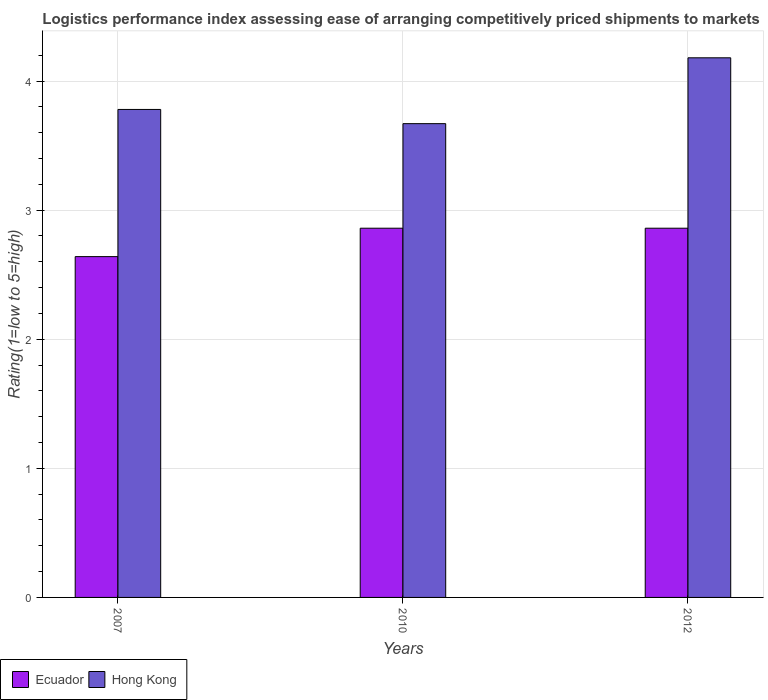Are the number of bars per tick equal to the number of legend labels?
Offer a very short reply. Yes. Are the number of bars on each tick of the X-axis equal?
Provide a short and direct response. Yes. What is the label of the 3rd group of bars from the left?
Your answer should be compact. 2012. In how many cases, is the number of bars for a given year not equal to the number of legend labels?
Ensure brevity in your answer.  0. What is the Logistic performance index in Hong Kong in 2012?
Offer a very short reply. 4.18. Across all years, what is the maximum Logistic performance index in Ecuador?
Offer a very short reply. 2.86. Across all years, what is the minimum Logistic performance index in Ecuador?
Provide a short and direct response. 2.64. What is the total Logistic performance index in Ecuador in the graph?
Give a very brief answer. 8.36. What is the difference between the Logistic performance index in Ecuador in 2007 and that in 2012?
Your answer should be very brief. -0.22. What is the difference between the Logistic performance index in Ecuador in 2007 and the Logistic performance index in Hong Kong in 2012?
Provide a succinct answer. -1.54. What is the average Logistic performance index in Ecuador per year?
Give a very brief answer. 2.79. In the year 2010, what is the difference between the Logistic performance index in Ecuador and Logistic performance index in Hong Kong?
Ensure brevity in your answer.  -0.81. What is the ratio of the Logistic performance index in Hong Kong in 2010 to that in 2012?
Provide a short and direct response. 0.88. Is the difference between the Logistic performance index in Ecuador in 2010 and 2012 greater than the difference between the Logistic performance index in Hong Kong in 2010 and 2012?
Your answer should be compact. Yes. What is the difference between the highest and the second highest Logistic performance index in Hong Kong?
Your answer should be very brief. 0.4. What is the difference between the highest and the lowest Logistic performance index in Hong Kong?
Make the answer very short. 0.51. In how many years, is the Logistic performance index in Hong Kong greater than the average Logistic performance index in Hong Kong taken over all years?
Offer a terse response. 1. What does the 2nd bar from the left in 2012 represents?
Your answer should be compact. Hong Kong. What does the 2nd bar from the right in 2010 represents?
Your response must be concise. Ecuador. How many bars are there?
Make the answer very short. 6. How many years are there in the graph?
Your answer should be compact. 3. Are the values on the major ticks of Y-axis written in scientific E-notation?
Provide a short and direct response. No. Does the graph contain any zero values?
Provide a succinct answer. No. How are the legend labels stacked?
Ensure brevity in your answer.  Horizontal. What is the title of the graph?
Keep it short and to the point. Logistics performance index assessing ease of arranging competitively priced shipments to markets. What is the label or title of the X-axis?
Keep it short and to the point. Years. What is the label or title of the Y-axis?
Offer a terse response. Rating(1=low to 5=high). What is the Rating(1=low to 5=high) in Ecuador in 2007?
Keep it short and to the point. 2.64. What is the Rating(1=low to 5=high) of Hong Kong in 2007?
Offer a terse response. 3.78. What is the Rating(1=low to 5=high) of Ecuador in 2010?
Your answer should be compact. 2.86. What is the Rating(1=low to 5=high) of Hong Kong in 2010?
Provide a short and direct response. 3.67. What is the Rating(1=low to 5=high) in Ecuador in 2012?
Provide a short and direct response. 2.86. What is the Rating(1=low to 5=high) in Hong Kong in 2012?
Your response must be concise. 4.18. Across all years, what is the maximum Rating(1=low to 5=high) of Ecuador?
Keep it short and to the point. 2.86. Across all years, what is the maximum Rating(1=low to 5=high) in Hong Kong?
Your answer should be very brief. 4.18. Across all years, what is the minimum Rating(1=low to 5=high) of Ecuador?
Your answer should be compact. 2.64. Across all years, what is the minimum Rating(1=low to 5=high) of Hong Kong?
Make the answer very short. 3.67. What is the total Rating(1=low to 5=high) in Ecuador in the graph?
Offer a very short reply. 8.36. What is the total Rating(1=low to 5=high) in Hong Kong in the graph?
Make the answer very short. 11.63. What is the difference between the Rating(1=low to 5=high) of Ecuador in 2007 and that in 2010?
Ensure brevity in your answer.  -0.22. What is the difference between the Rating(1=low to 5=high) of Hong Kong in 2007 and that in 2010?
Offer a terse response. 0.11. What is the difference between the Rating(1=low to 5=high) in Ecuador in 2007 and that in 2012?
Make the answer very short. -0.22. What is the difference between the Rating(1=low to 5=high) in Hong Kong in 2007 and that in 2012?
Your response must be concise. -0.4. What is the difference between the Rating(1=low to 5=high) of Ecuador in 2010 and that in 2012?
Keep it short and to the point. 0. What is the difference between the Rating(1=low to 5=high) of Hong Kong in 2010 and that in 2012?
Ensure brevity in your answer.  -0.51. What is the difference between the Rating(1=low to 5=high) in Ecuador in 2007 and the Rating(1=low to 5=high) in Hong Kong in 2010?
Make the answer very short. -1.03. What is the difference between the Rating(1=low to 5=high) in Ecuador in 2007 and the Rating(1=low to 5=high) in Hong Kong in 2012?
Make the answer very short. -1.54. What is the difference between the Rating(1=low to 5=high) of Ecuador in 2010 and the Rating(1=low to 5=high) of Hong Kong in 2012?
Make the answer very short. -1.32. What is the average Rating(1=low to 5=high) in Ecuador per year?
Offer a terse response. 2.79. What is the average Rating(1=low to 5=high) in Hong Kong per year?
Your response must be concise. 3.88. In the year 2007, what is the difference between the Rating(1=low to 5=high) of Ecuador and Rating(1=low to 5=high) of Hong Kong?
Make the answer very short. -1.14. In the year 2010, what is the difference between the Rating(1=low to 5=high) of Ecuador and Rating(1=low to 5=high) of Hong Kong?
Provide a short and direct response. -0.81. In the year 2012, what is the difference between the Rating(1=low to 5=high) in Ecuador and Rating(1=low to 5=high) in Hong Kong?
Provide a short and direct response. -1.32. What is the ratio of the Rating(1=low to 5=high) of Hong Kong in 2007 to that in 2010?
Keep it short and to the point. 1.03. What is the ratio of the Rating(1=low to 5=high) in Ecuador in 2007 to that in 2012?
Make the answer very short. 0.92. What is the ratio of the Rating(1=low to 5=high) of Hong Kong in 2007 to that in 2012?
Keep it short and to the point. 0.9. What is the ratio of the Rating(1=low to 5=high) in Ecuador in 2010 to that in 2012?
Give a very brief answer. 1. What is the ratio of the Rating(1=low to 5=high) of Hong Kong in 2010 to that in 2012?
Your answer should be compact. 0.88. What is the difference between the highest and the second highest Rating(1=low to 5=high) in Ecuador?
Ensure brevity in your answer.  0. What is the difference between the highest and the lowest Rating(1=low to 5=high) in Ecuador?
Your answer should be compact. 0.22. What is the difference between the highest and the lowest Rating(1=low to 5=high) in Hong Kong?
Ensure brevity in your answer.  0.51. 